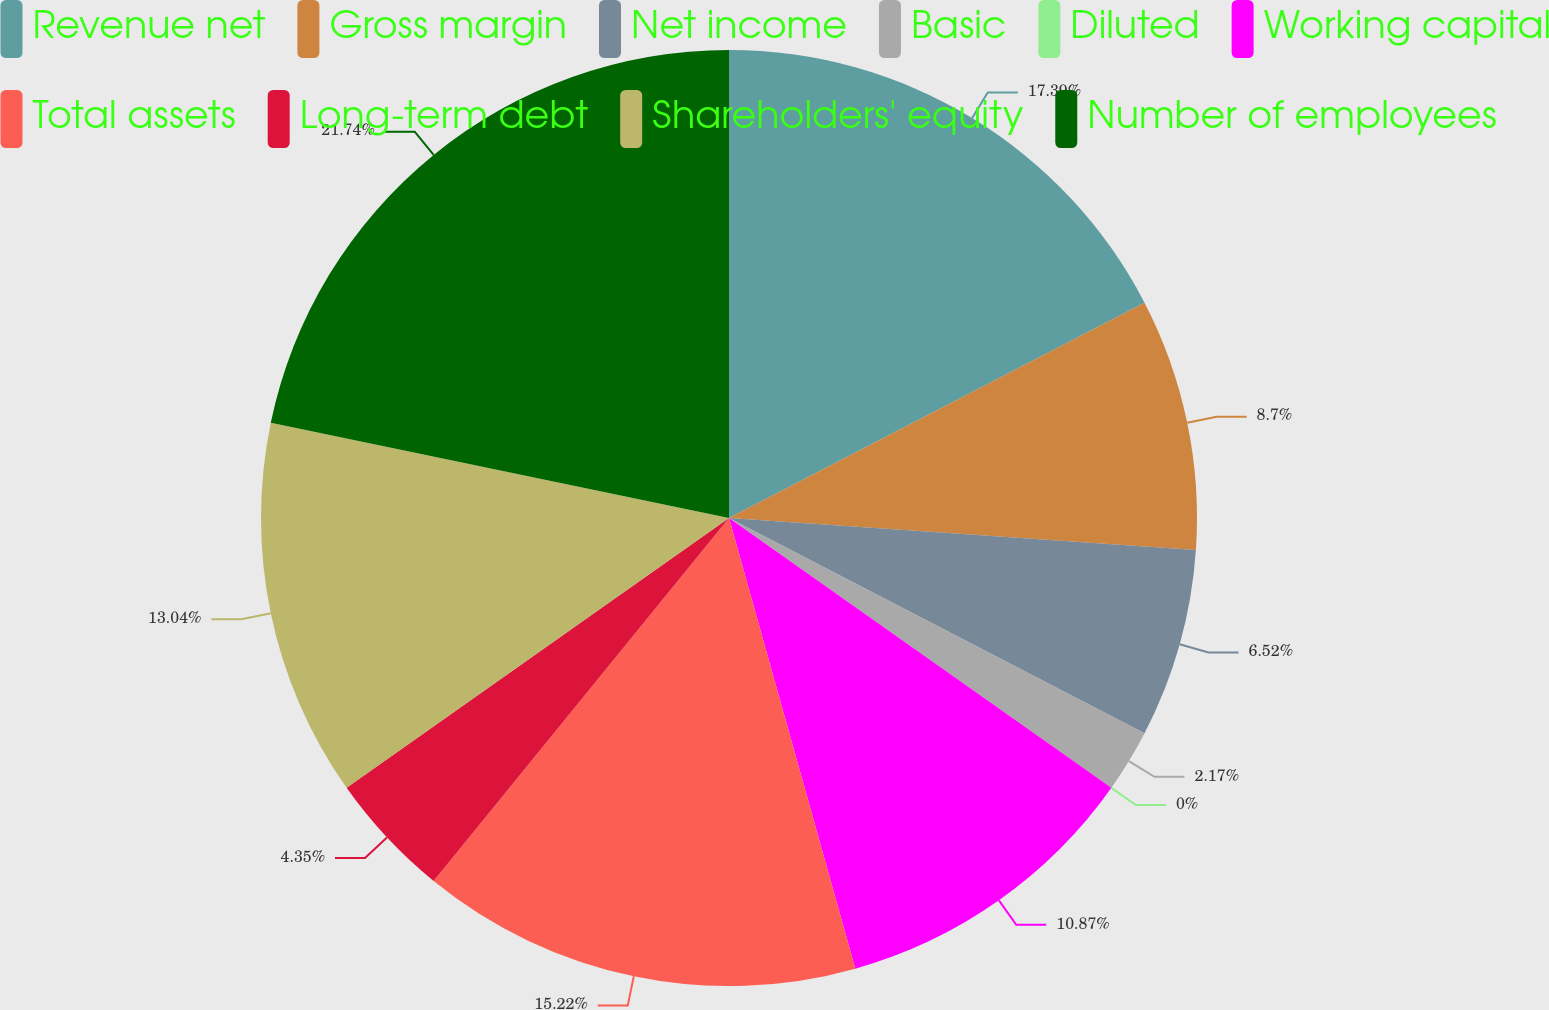Convert chart to OTSL. <chart><loc_0><loc_0><loc_500><loc_500><pie_chart><fcel>Revenue net<fcel>Gross margin<fcel>Net income<fcel>Basic<fcel>Diluted<fcel>Working capital<fcel>Total assets<fcel>Long-term debt<fcel>Shareholders' equity<fcel>Number of employees<nl><fcel>17.39%<fcel>8.7%<fcel>6.52%<fcel>2.17%<fcel>0.0%<fcel>10.87%<fcel>15.22%<fcel>4.35%<fcel>13.04%<fcel>21.74%<nl></chart> 